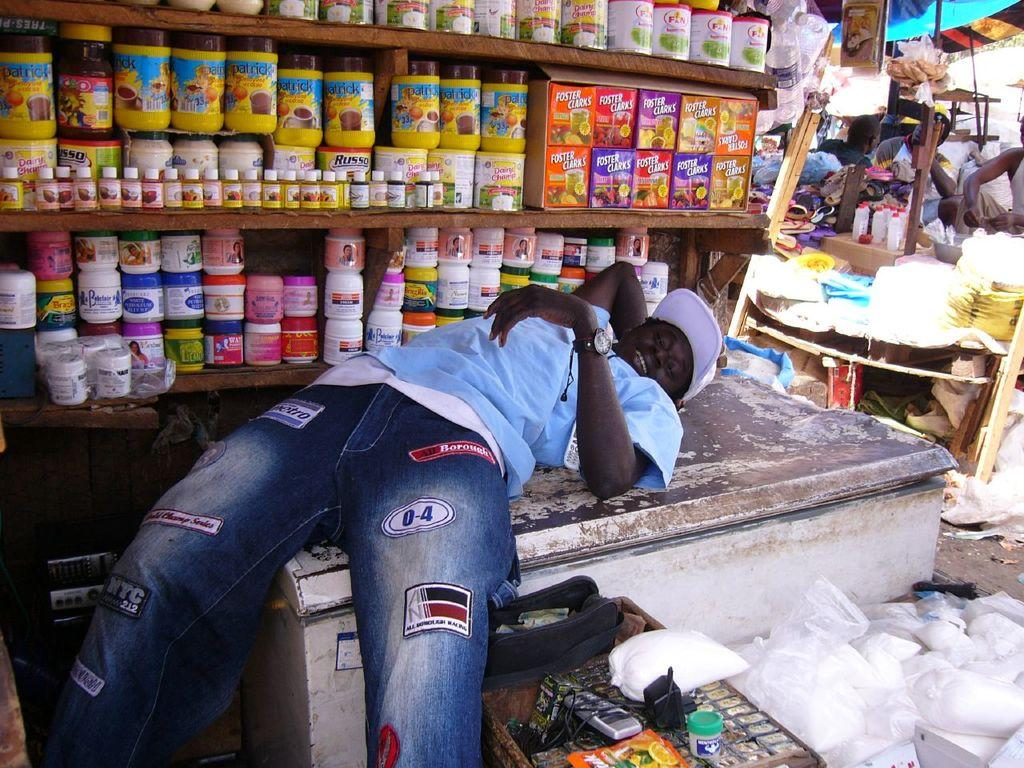Who or what is present in the image? There is a person in the image. What type of furniture is visible in the image? There are shelves and a table in the image. What objects can be seen on the shelves and table? There are boxes, bottles, and a mobile phone on the table in the image. What type of root can be seen growing from the person's head in the image? There is no root growing from the person's head in the image. Is the person walking through quicksand in the image? There is no quicksand present in the image. 